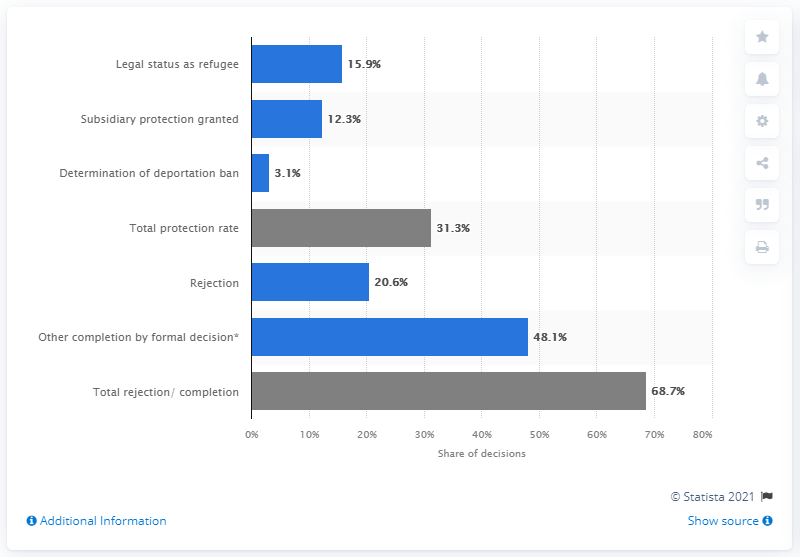List a handful of essential elements in this visual. In 2021, 15.9% of Germans obtained legal status as refugees. 